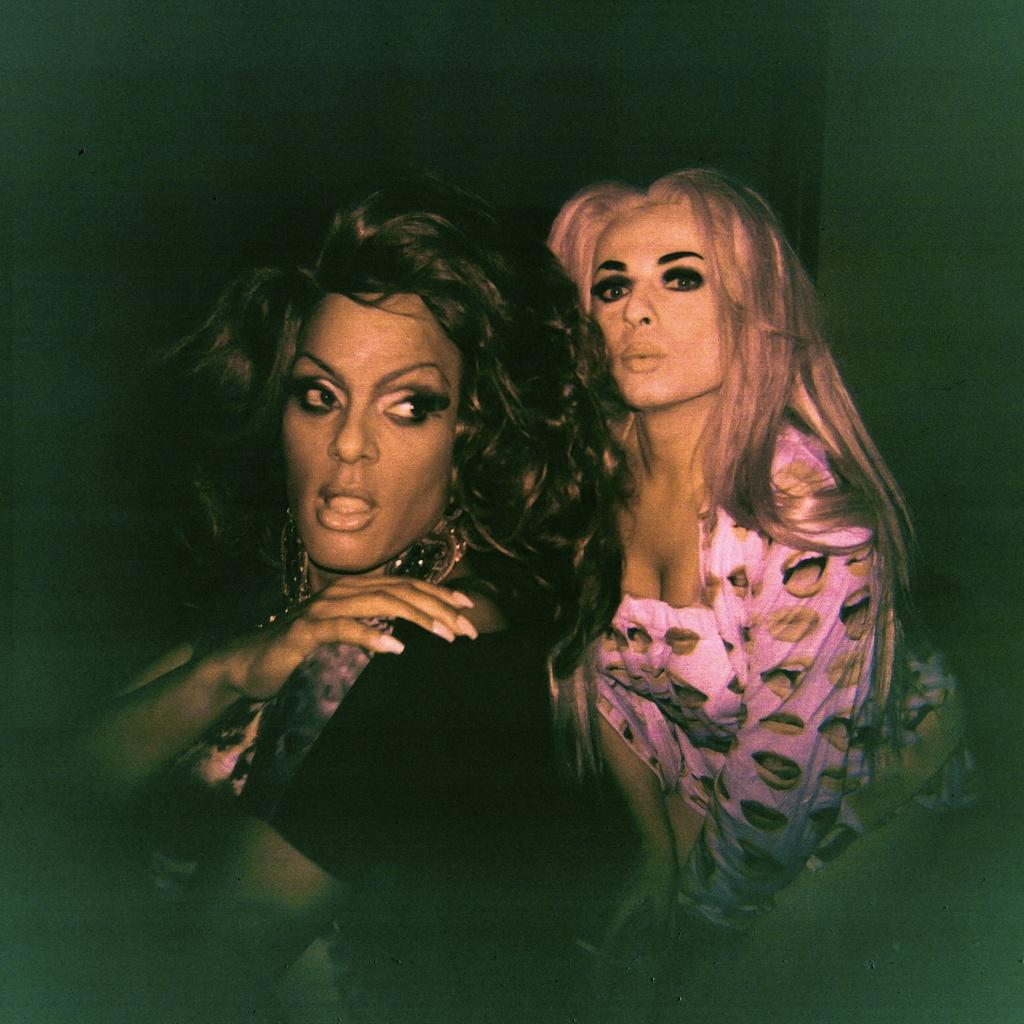What is the main subject of the image? The main subject of the image is women standing. Can you describe the background of the image? The background of the image is dark. What type of heat source can be seen in the image? There is no heat source present in the image. What word is written on the wall in the image? There is no word written on the wall in the image. 